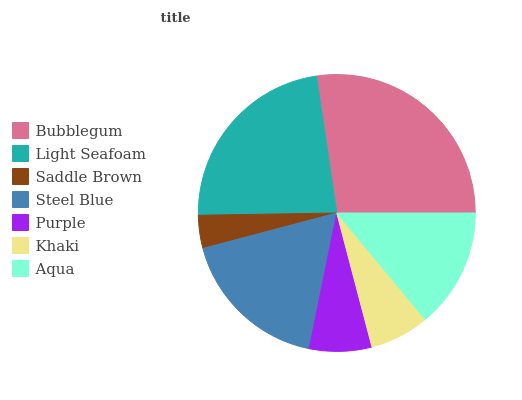Is Saddle Brown the minimum?
Answer yes or no. Yes. Is Bubblegum the maximum?
Answer yes or no. Yes. Is Light Seafoam the minimum?
Answer yes or no. No. Is Light Seafoam the maximum?
Answer yes or no. No. Is Bubblegum greater than Light Seafoam?
Answer yes or no. Yes. Is Light Seafoam less than Bubblegum?
Answer yes or no. Yes. Is Light Seafoam greater than Bubblegum?
Answer yes or no. No. Is Bubblegum less than Light Seafoam?
Answer yes or no. No. Is Aqua the high median?
Answer yes or no. Yes. Is Aqua the low median?
Answer yes or no. Yes. Is Light Seafoam the high median?
Answer yes or no. No. Is Saddle Brown the low median?
Answer yes or no. No. 